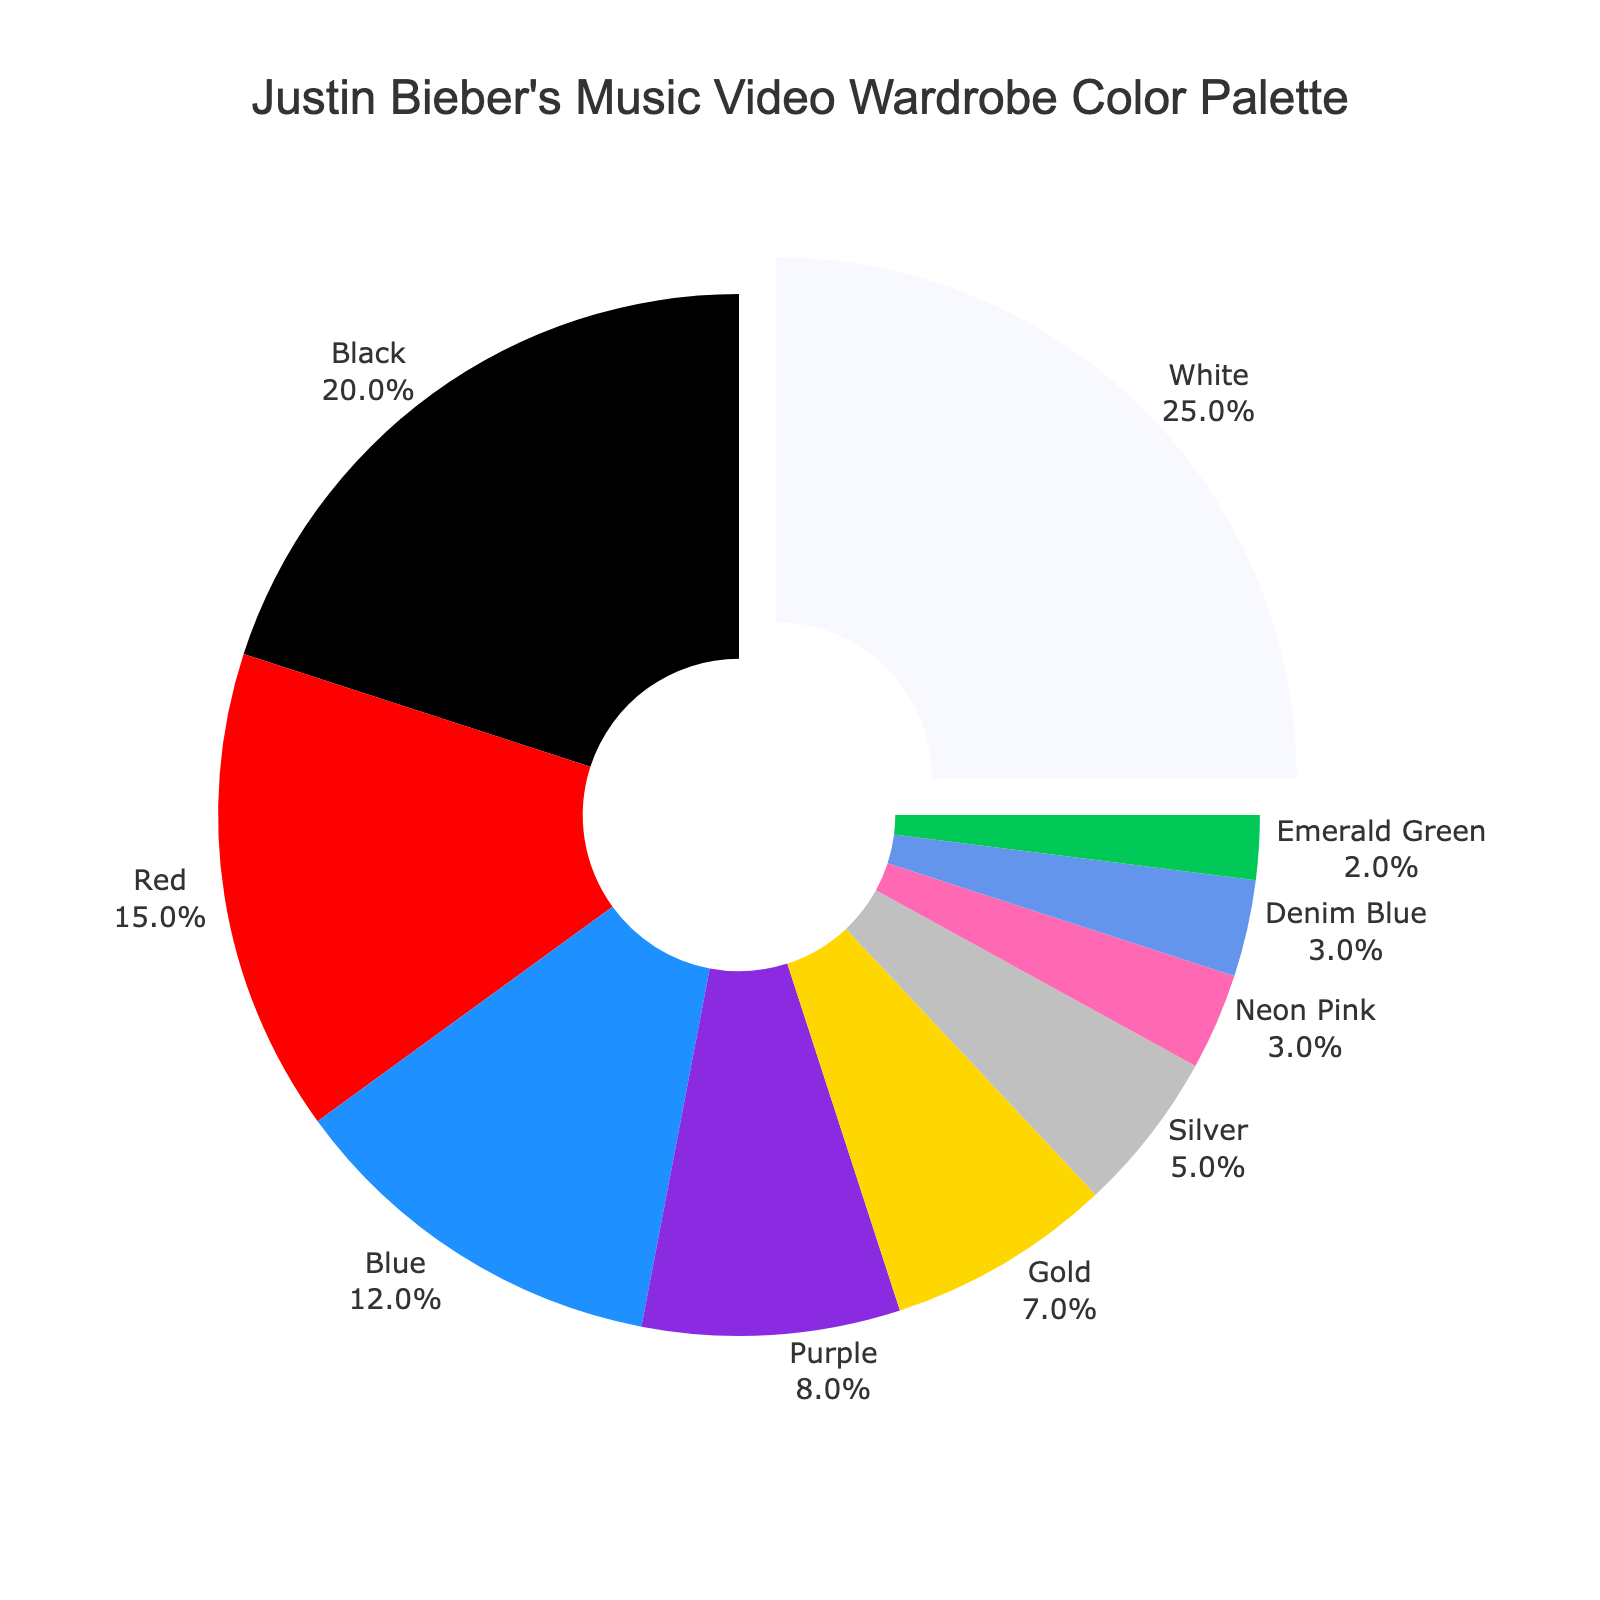What is the most dominant color in Justin Bieber's music video wardrobe? White occupies the largest slice of the pie chart, showing 25% of the color palette.
Answer: White Which two colors collectively contribute 35% to the wardrobe color palette? By adding the two percentages, Black (20%) and Red (15%) together, we get 20% + 15% = 35%.
Answer: Black and Red How much more percentage does White have compared to Black in Justin Bieber’s music video wardrobe color palette? White's percentage is 25% and Black's is 20%. The difference is 25% - 20% = 5%.
Answer: 5% What is the combined percentage of the least used three colors in the wardrobe palette? The least used three colors are Denim Blue (3%), Neon Pink (3%), and Emerald Green (2%). Summing them up: 3% + 3% + 2% = 8%.
Answer: 8% Which colors, when added together, make up exactly half of the total color palette? Purple (8%), Gold (7%), Silver (5%), Neon Pink (3%), Denim Blue (3%), and Emerald Green (2%) combined give: 8% + 7% + 5% + 3% + 3% + 2% = 28%. Adding Red (15%) and Blue (12%) together, gives 15% + 12% = 27%. Lastly, Black (20%) and Blue (12%) give 20% + 12% = 32%. So, Blue (12%) and the combination of Purple (8%), Gold (7%), and Silver (5%) together total 32%.
Answer: Purple, Gold, Silver, Neon Pink, Denim Blue, and Emerald Green What color slice appears visually the smallest in the pie chart? The smallest slice visually representing the color palette is Emerald Green which is 2%.
Answer: Emerald Green Which colors have a pull-out effect, indicating they are the most significant? The pie slice for White is pulled out, signifying White has the highest percentage.
Answer: White Compare the combined percentage of Blue and Purple to Red. Which is greater? Blue is 12% and Purple is 8%. Combined, they make 12% + 8% = 20%. Red alone is 15%, so 20% is greater than 15%.
Answer: Blue and Purple Which color occupies just over one-tenth of the color palette in the pie chart? Blue occupies 12%, which is slightly more than one-tenth of the total 100%.
Answer: Blue How many colors constitute less than 5% each of the wardrobe color palette? Silver (5%), Neon Pink (3%), Denim Blue (3%), and Emerald Green (2%) all make up less than 5% each. There are 4 such colors.
Answer: 4 